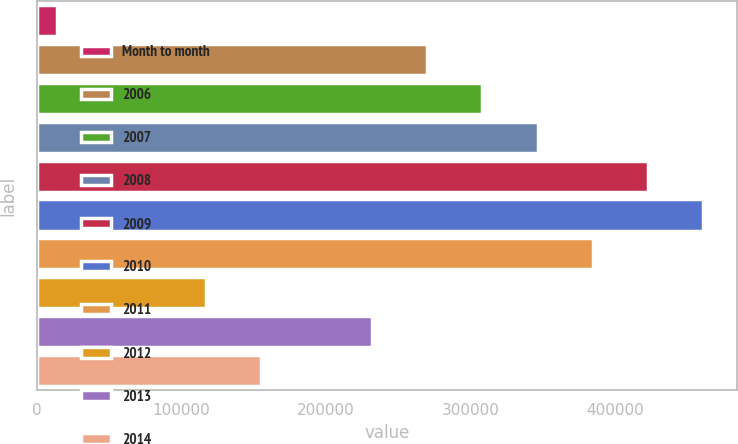Convert chart to OTSL. <chart><loc_0><loc_0><loc_500><loc_500><bar_chart><fcel>Month to month<fcel>2006<fcel>2007<fcel>2008<fcel>2009<fcel>2010<fcel>2011<fcel>2012<fcel>2013<fcel>2014<nl><fcel>14000<fcel>269800<fcel>308000<fcel>346200<fcel>422600<fcel>460800<fcel>384400<fcel>117000<fcel>231600<fcel>155200<nl></chart> 